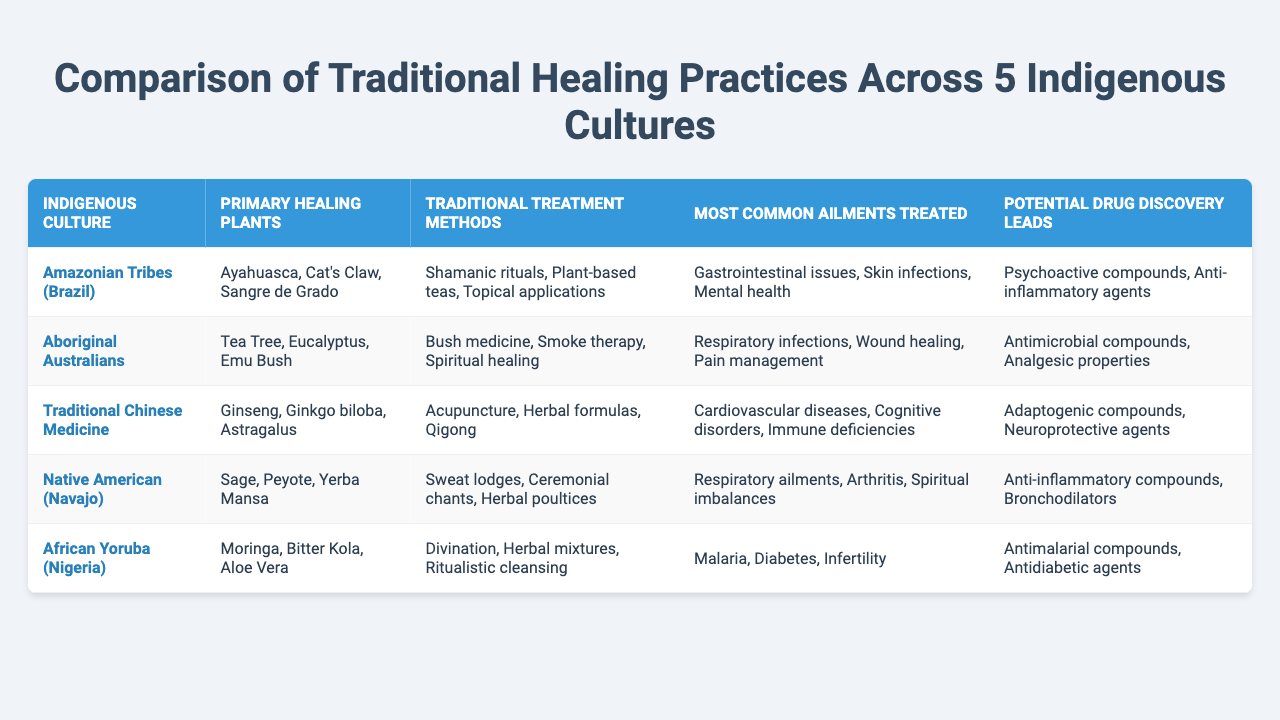What is the primary healing plant used by Aboriginal Australians? According to the table, the primary healing plants used by Aboriginal Australians are Tea Tree, Eucalyptus, and Emu Bush. The answer is clearly listed under the "Primary Healing Plants" column.
Answer: Tea Tree, Eucalyptus, Emu Bush Which indigenous culture uses Ayahuasca as a healing plant? The table states that Ayahuasca is listed under the "Primary Healing Plants" for the Amazonian Tribes (Brazil). Therefore, the indigenous culture that uses Ayahuasca is the Amazonian Tribes.
Answer: Amazonian Tribes (Brazil) What traditional treatment methods are utilized by Native Americans (Navajo)? The table provides the information that Native Americans (Navajo) use Sweat lodges, Ceremonial chants, and Herbal poultices as their traditional treatment methods, as indicated in the "Traditional Treatment Methods" column.
Answer: Sweat lodges, Ceremonial chants, Herbal poultices Which culture treats malaria and what potential drug discovery leads are associated? The table indicates that the African Yoruba (Nigeria) culture treats malaria, and the associated potential drug discovery leads are Antimalarial compounds. This can be found under the respective columns.
Answer: African Yoruba (Nigeria), Antimalarial compounds Are there any cultures that treat respiratory infections? Yes, the table shows that both Aboriginal Australians and Native American (Navajo) cultures treat respiratory infections, as this is mentioned in their "Most Common Ailments Treated" section.
Answer: Yes Which region has the most diverse range of traditional healing plants listed? By comparing the "Primary Healing Plants" across each culture in the table, the Amazonian Tribes (Brazil) have three unique plants associated, while other cultures have only two or three listed but with more redundancy in their application. Therefore, the Amazonian Tribes have a wider variety in this context.
Answer: Amazonian Tribes (Brazil) If the treatments for pain management are combined from the Aboriginal Australians and Native American (Navajo), which plants contribute to this? The Aboriginal Australians contribute Tea Tree, Eucalyptus, and Emu Bush for pain management, and the Native American (Navajo) contribute Sage, Peyote, and Yerba Mansa. Adding them would give a total of six plants involved in pain management across these cultures.
Answer: Six plants What common ailments do both Traditional Chinese Medicine and Native American cultures treat? By reviewing the "Most Common Ailments Treated" column, Traditional Chinese Medicine addresses cardiovascular diseases and cognitive disorders, while Native Americans focus on respiratory ailments and spiritual imbalances. There is no overlap in their most common ailments treated.
Answer: None Which indigenous culture has the most potential drug discovery leads listed? Upon analyzing the table, each culture offers two specific leads, however, the Amazonian Tribes (Brazil) and the Native American (Navajo) cultures list two distinct potential leads. Consequently, there is no clear culture that stands out with more leads.
Answer: None, they are equal 